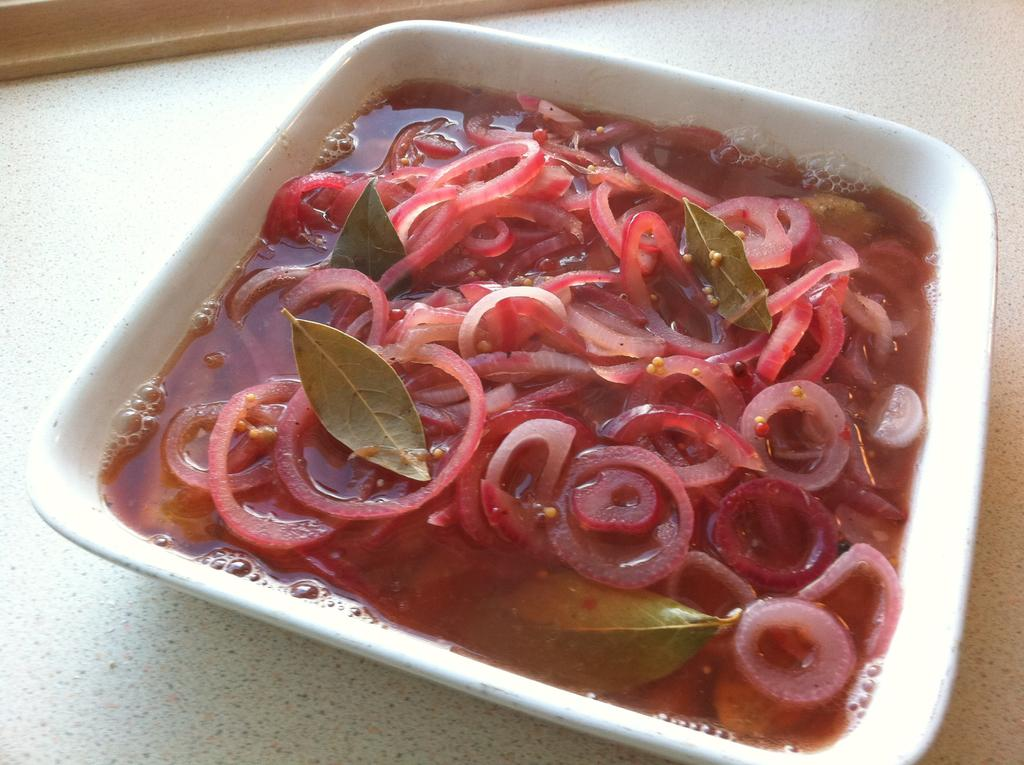What type of vegetable is in the bowl in the image? There are red onions in a bowl in the image. Can you see a snake slithering through the red onions in the image? No, there is no snake present in the image; it only features red onions in a bowl. 